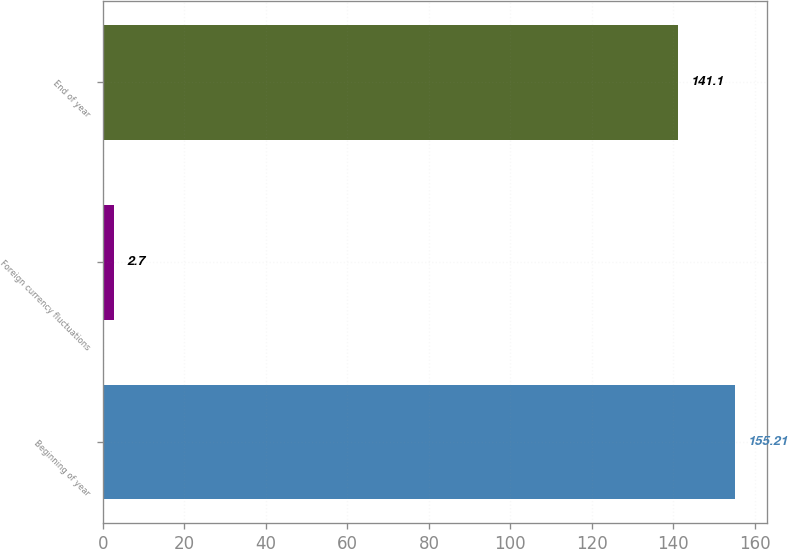<chart> <loc_0><loc_0><loc_500><loc_500><bar_chart><fcel>Beginning of year<fcel>Foreign currency fluctuations<fcel>End of year<nl><fcel>155.21<fcel>2.7<fcel>141.1<nl></chart> 